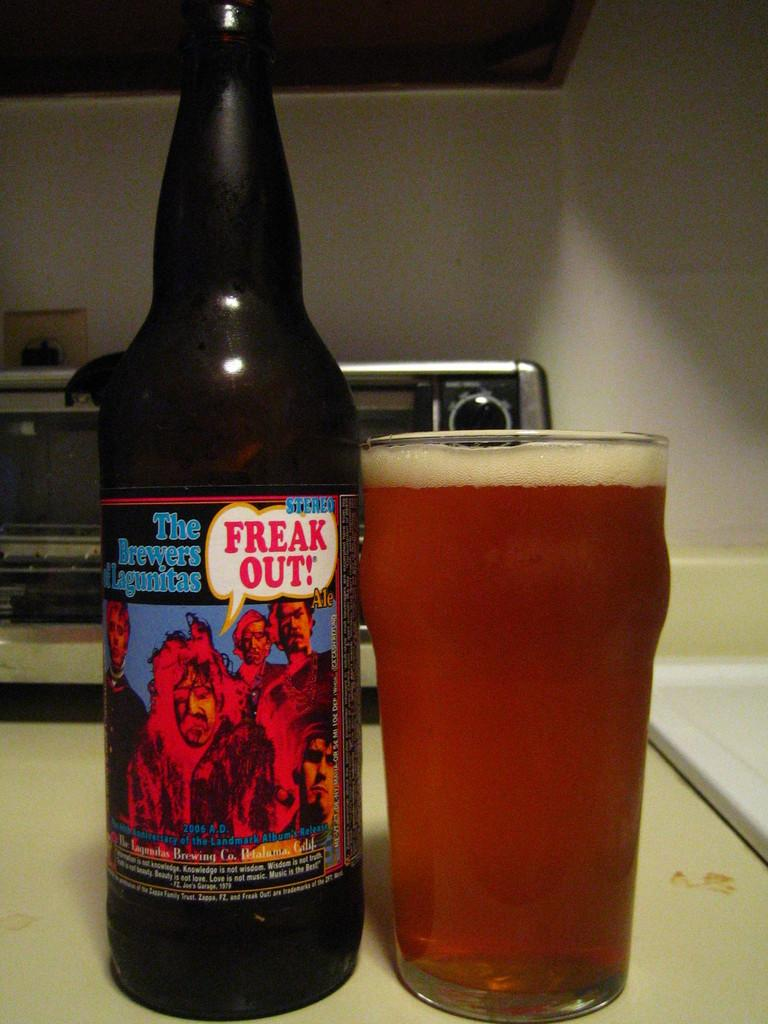Provide a one-sentence caption for the provided image. A bottle of the brewers Lagunitas next to a full glass of it. 